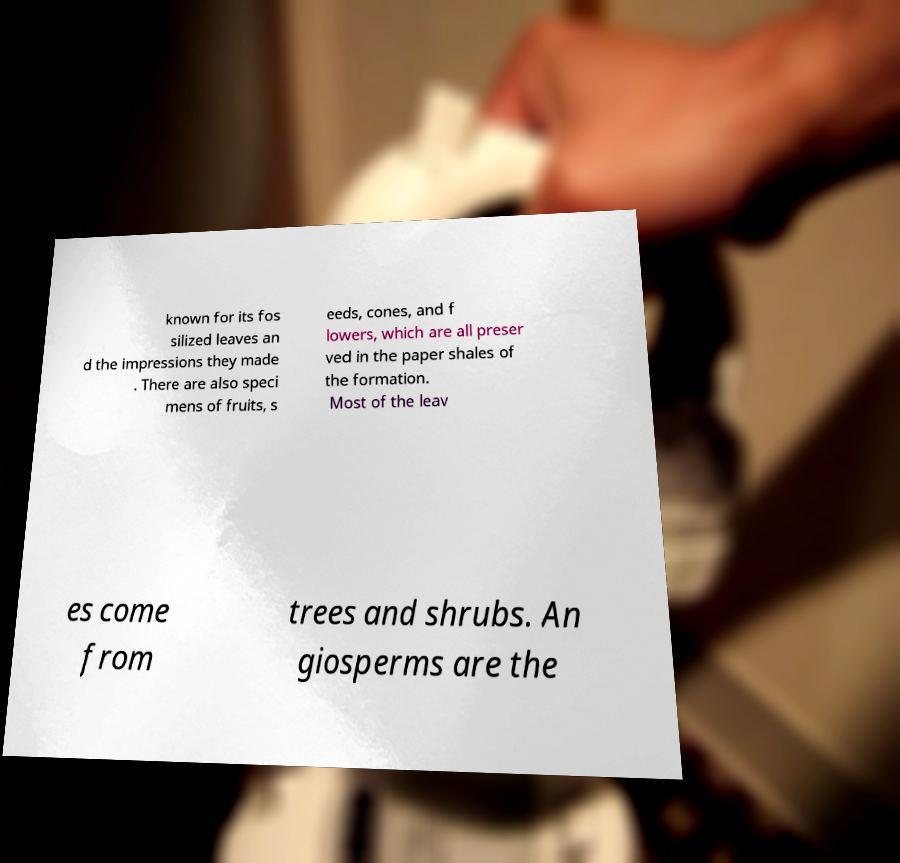Could you extract and type out the text from this image? known for its fos silized leaves an d the impressions they made . There are also speci mens of fruits, s eeds, cones, and f lowers, which are all preser ved in the paper shales of the formation. Most of the leav es come from trees and shrubs. An giosperms are the 